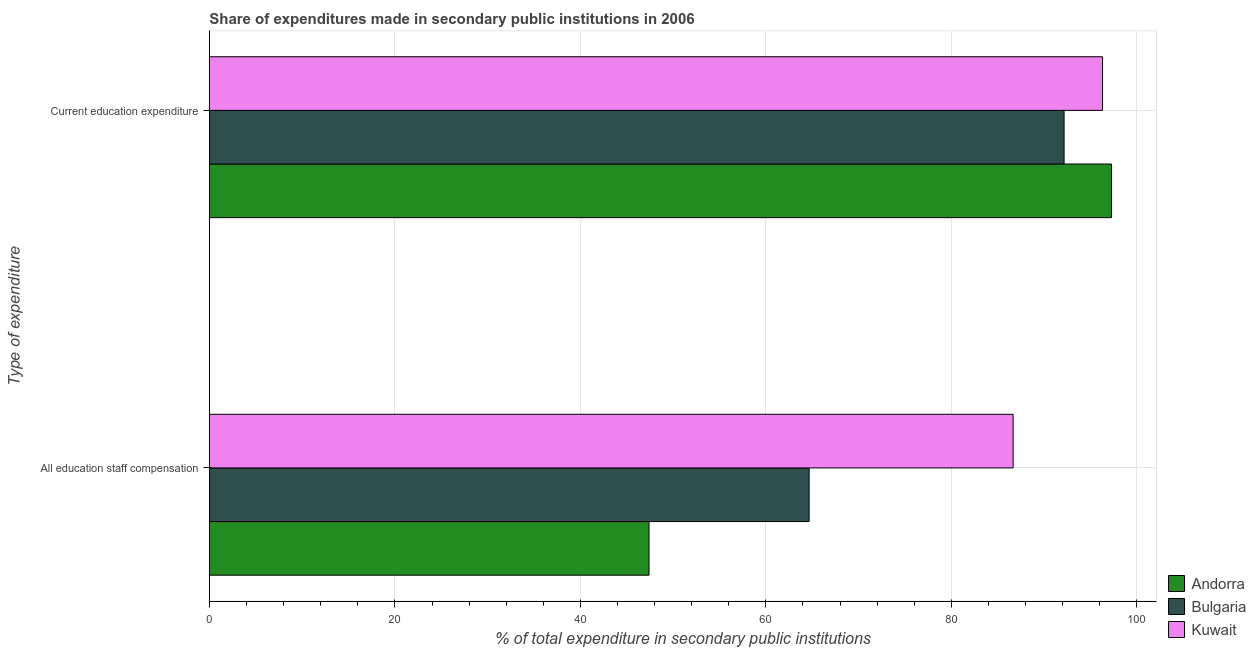How many different coloured bars are there?
Your answer should be very brief. 3. How many bars are there on the 2nd tick from the top?
Keep it short and to the point. 3. What is the label of the 2nd group of bars from the top?
Ensure brevity in your answer.  All education staff compensation. What is the expenditure in education in Kuwait?
Provide a short and direct response. 96.3. Across all countries, what is the maximum expenditure in education?
Provide a short and direct response. 97.26. Across all countries, what is the minimum expenditure in staff compensation?
Offer a very short reply. 47.4. In which country was the expenditure in staff compensation maximum?
Ensure brevity in your answer.  Kuwait. In which country was the expenditure in staff compensation minimum?
Your answer should be compact. Andorra. What is the total expenditure in staff compensation in the graph?
Offer a terse response. 198.72. What is the difference between the expenditure in staff compensation in Bulgaria and that in Andorra?
Offer a very short reply. 17.26. What is the difference between the expenditure in staff compensation in Andorra and the expenditure in education in Kuwait?
Your answer should be compact. -48.9. What is the average expenditure in education per country?
Your answer should be very brief. 95.24. What is the difference between the expenditure in staff compensation and expenditure in education in Andorra?
Your answer should be compact. -49.86. In how many countries, is the expenditure in staff compensation greater than 84 %?
Provide a short and direct response. 1. What is the ratio of the expenditure in education in Andorra to that in Kuwait?
Give a very brief answer. 1.01. In how many countries, is the expenditure in staff compensation greater than the average expenditure in staff compensation taken over all countries?
Offer a terse response. 1. What does the 1st bar from the top in All education staff compensation represents?
Offer a terse response. Kuwait. What does the 3rd bar from the bottom in Current education expenditure represents?
Give a very brief answer. Kuwait. How many bars are there?
Keep it short and to the point. 6. What is the difference between two consecutive major ticks on the X-axis?
Ensure brevity in your answer.  20. Are the values on the major ticks of X-axis written in scientific E-notation?
Ensure brevity in your answer.  No. How are the legend labels stacked?
Give a very brief answer. Vertical. What is the title of the graph?
Offer a terse response. Share of expenditures made in secondary public institutions in 2006. What is the label or title of the X-axis?
Your answer should be compact. % of total expenditure in secondary public institutions. What is the label or title of the Y-axis?
Keep it short and to the point. Type of expenditure. What is the % of total expenditure in secondary public institutions of Andorra in All education staff compensation?
Your answer should be very brief. 47.4. What is the % of total expenditure in secondary public institutions of Bulgaria in All education staff compensation?
Make the answer very short. 64.66. What is the % of total expenditure in secondary public institutions in Kuwait in All education staff compensation?
Ensure brevity in your answer.  86.66. What is the % of total expenditure in secondary public institutions in Andorra in Current education expenditure?
Keep it short and to the point. 97.26. What is the % of total expenditure in secondary public institutions in Bulgaria in Current education expenditure?
Keep it short and to the point. 92.15. What is the % of total expenditure in secondary public institutions of Kuwait in Current education expenditure?
Offer a very short reply. 96.3. Across all Type of expenditure, what is the maximum % of total expenditure in secondary public institutions in Andorra?
Your response must be concise. 97.26. Across all Type of expenditure, what is the maximum % of total expenditure in secondary public institutions of Bulgaria?
Provide a succinct answer. 92.15. Across all Type of expenditure, what is the maximum % of total expenditure in secondary public institutions in Kuwait?
Provide a short and direct response. 96.3. Across all Type of expenditure, what is the minimum % of total expenditure in secondary public institutions in Andorra?
Provide a short and direct response. 47.4. Across all Type of expenditure, what is the minimum % of total expenditure in secondary public institutions of Bulgaria?
Your answer should be compact. 64.66. Across all Type of expenditure, what is the minimum % of total expenditure in secondary public institutions of Kuwait?
Offer a very short reply. 86.66. What is the total % of total expenditure in secondary public institutions of Andorra in the graph?
Keep it short and to the point. 144.66. What is the total % of total expenditure in secondary public institutions of Bulgaria in the graph?
Keep it short and to the point. 156.82. What is the total % of total expenditure in secondary public institutions in Kuwait in the graph?
Provide a succinct answer. 182.96. What is the difference between the % of total expenditure in secondary public institutions in Andorra in All education staff compensation and that in Current education expenditure?
Provide a short and direct response. -49.86. What is the difference between the % of total expenditure in secondary public institutions in Bulgaria in All education staff compensation and that in Current education expenditure?
Your response must be concise. -27.49. What is the difference between the % of total expenditure in secondary public institutions of Kuwait in All education staff compensation and that in Current education expenditure?
Offer a very short reply. -9.64. What is the difference between the % of total expenditure in secondary public institutions of Andorra in All education staff compensation and the % of total expenditure in secondary public institutions of Bulgaria in Current education expenditure?
Provide a succinct answer. -44.76. What is the difference between the % of total expenditure in secondary public institutions in Andorra in All education staff compensation and the % of total expenditure in secondary public institutions in Kuwait in Current education expenditure?
Your response must be concise. -48.9. What is the difference between the % of total expenditure in secondary public institutions of Bulgaria in All education staff compensation and the % of total expenditure in secondary public institutions of Kuwait in Current education expenditure?
Offer a terse response. -31.64. What is the average % of total expenditure in secondary public institutions in Andorra per Type of expenditure?
Make the answer very short. 72.33. What is the average % of total expenditure in secondary public institutions of Bulgaria per Type of expenditure?
Your answer should be compact. 78.41. What is the average % of total expenditure in secondary public institutions in Kuwait per Type of expenditure?
Ensure brevity in your answer.  91.48. What is the difference between the % of total expenditure in secondary public institutions in Andorra and % of total expenditure in secondary public institutions in Bulgaria in All education staff compensation?
Make the answer very short. -17.26. What is the difference between the % of total expenditure in secondary public institutions of Andorra and % of total expenditure in secondary public institutions of Kuwait in All education staff compensation?
Your answer should be very brief. -39.26. What is the difference between the % of total expenditure in secondary public institutions of Bulgaria and % of total expenditure in secondary public institutions of Kuwait in All education staff compensation?
Offer a terse response. -22. What is the difference between the % of total expenditure in secondary public institutions of Andorra and % of total expenditure in secondary public institutions of Bulgaria in Current education expenditure?
Offer a terse response. 5.11. What is the difference between the % of total expenditure in secondary public institutions of Andorra and % of total expenditure in secondary public institutions of Kuwait in Current education expenditure?
Offer a terse response. 0.96. What is the difference between the % of total expenditure in secondary public institutions of Bulgaria and % of total expenditure in secondary public institutions of Kuwait in Current education expenditure?
Ensure brevity in your answer.  -4.15. What is the ratio of the % of total expenditure in secondary public institutions of Andorra in All education staff compensation to that in Current education expenditure?
Provide a short and direct response. 0.49. What is the ratio of the % of total expenditure in secondary public institutions of Bulgaria in All education staff compensation to that in Current education expenditure?
Offer a terse response. 0.7. What is the ratio of the % of total expenditure in secondary public institutions of Kuwait in All education staff compensation to that in Current education expenditure?
Provide a short and direct response. 0.9. What is the difference between the highest and the second highest % of total expenditure in secondary public institutions in Andorra?
Provide a succinct answer. 49.86. What is the difference between the highest and the second highest % of total expenditure in secondary public institutions of Bulgaria?
Your answer should be compact. 27.49. What is the difference between the highest and the second highest % of total expenditure in secondary public institutions of Kuwait?
Provide a succinct answer. 9.64. What is the difference between the highest and the lowest % of total expenditure in secondary public institutions in Andorra?
Your response must be concise. 49.86. What is the difference between the highest and the lowest % of total expenditure in secondary public institutions of Bulgaria?
Provide a short and direct response. 27.49. What is the difference between the highest and the lowest % of total expenditure in secondary public institutions of Kuwait?
Make the answer very short. 9.64. 